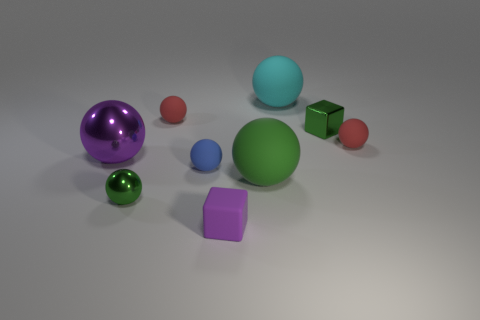There is a large object that is the same color as the small metallic ball; what material is it?
Your response must be concise. Rubber. What number of matte balls are the same color as the shiny block?
Offer a very short reply. 1. Is the green rubber thing the same size as the blue rubber object?
Give a very brief answer. No. What number of things are balls that are in front of the large cyan object or red spheres that are to the left of the small purple matte object?
Keep it short and to the point. 6. Is the number of big metallic things to the left of the purple metal object greater than the number of cyan balls?
Keep it short and to the point. No. What number of other objects are there of the same shape as the cyan rubber object?
Offer a very short reply. 6. There is a ball that is both in front of the green shiny cube and right of the green matte object; what is its material?
Ensure brevity in your answer.  Rubber. How many objects are cyan blocks or green balls?
Provide a succinct answer. 2. Are there more large shiny things than large purple cylinders?
Keep it short and to the point. Yes. There is a red matte ball that is right of the purple object that is in front of the purple shiny object; what size is it?
Give a very brief answer. Small. 